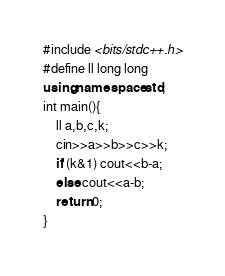<code> <loc_0><loc_0><loc_500><loc_500><_C++_>#include <bits/stdc++.h>
#define ll long long
using namespace std;
int main(){
    ll a,b,c,k;
    cin>>a>>b>>c>>k;
    if (k&1) cout<<b-a;
    else cout<<a-b;
    return 0;
}
</code> 